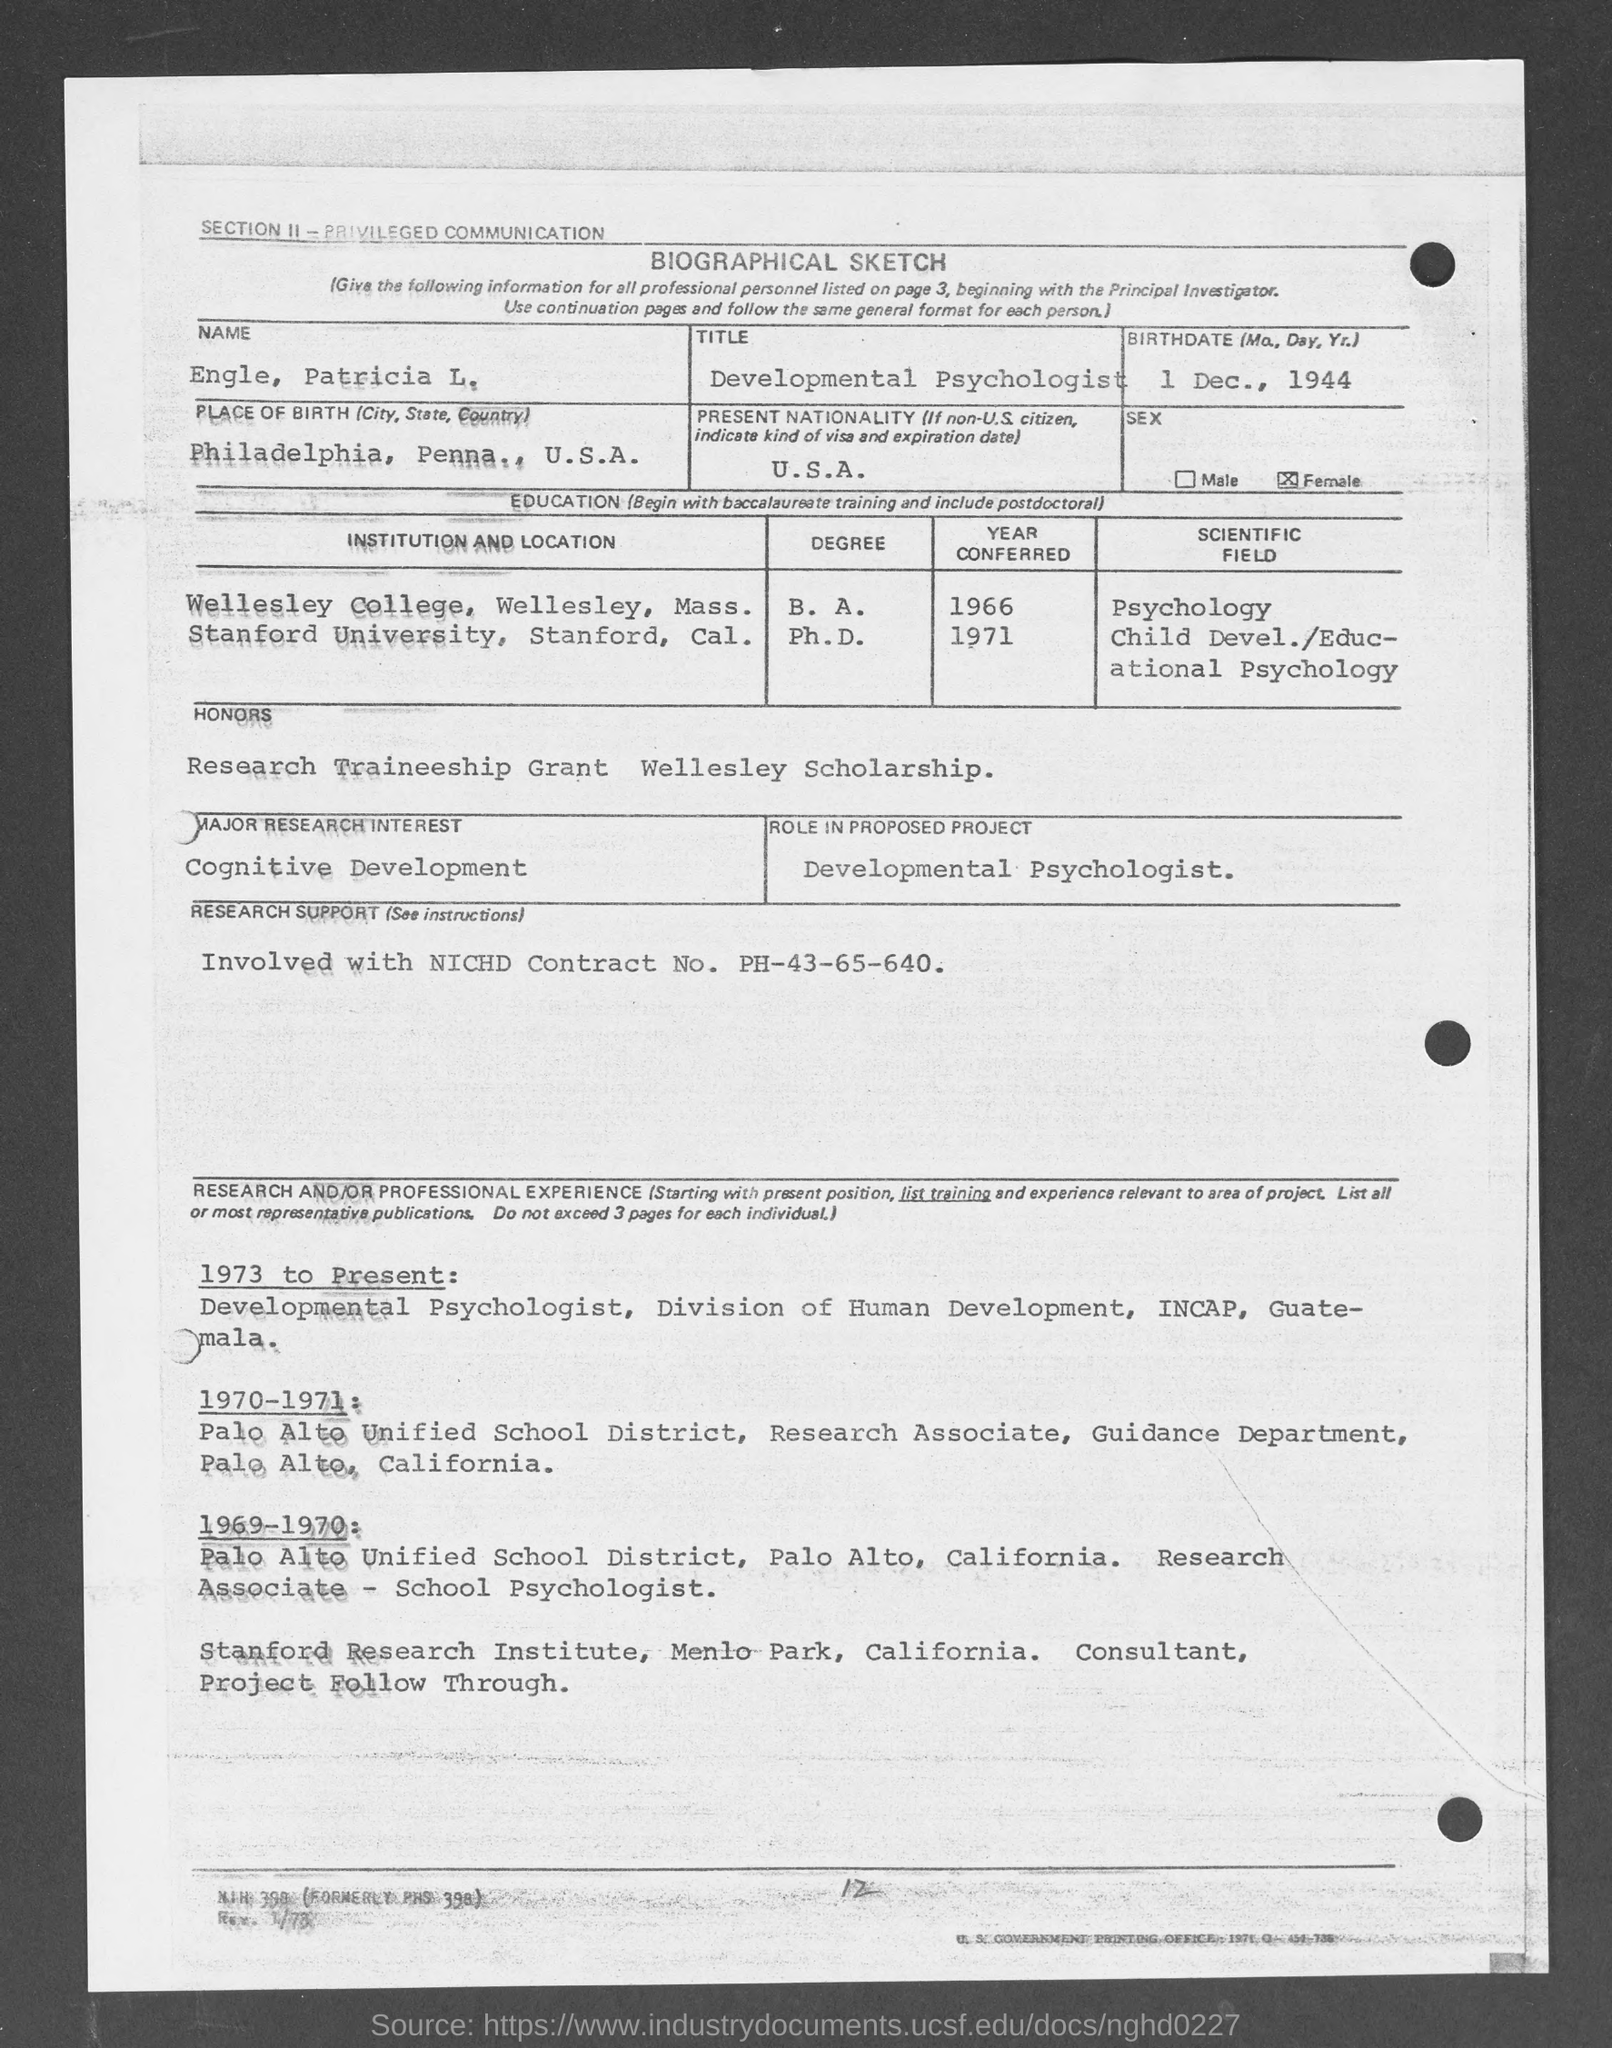List a handful of essential elements in this visual. She attended Stanford University in Stanford, California in 1971. Wellesley College was attended by the subject in 1966. On December 1st, 1944, the person's birthdate was. The title of the document is 'Biographical Sketch,' which provides a detailed account of the subject's life and achievements. The name is Engle, Patricia L.... 